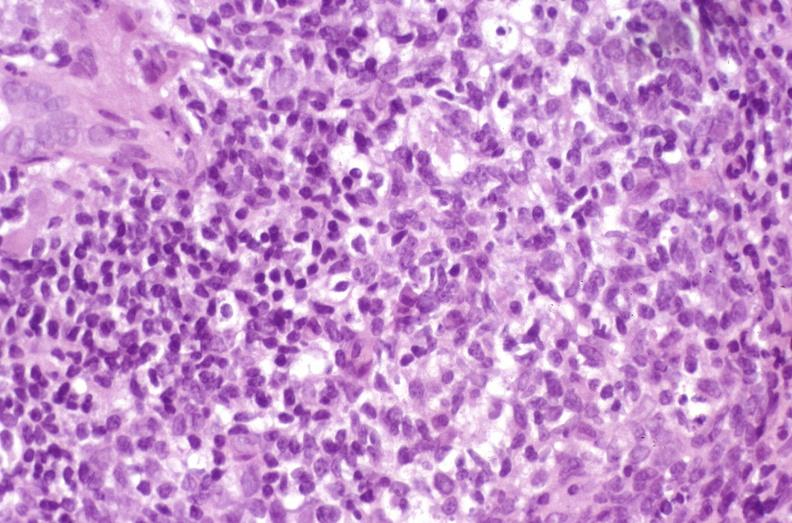what is present?
Answer the question using a single word or phrase. Liver 